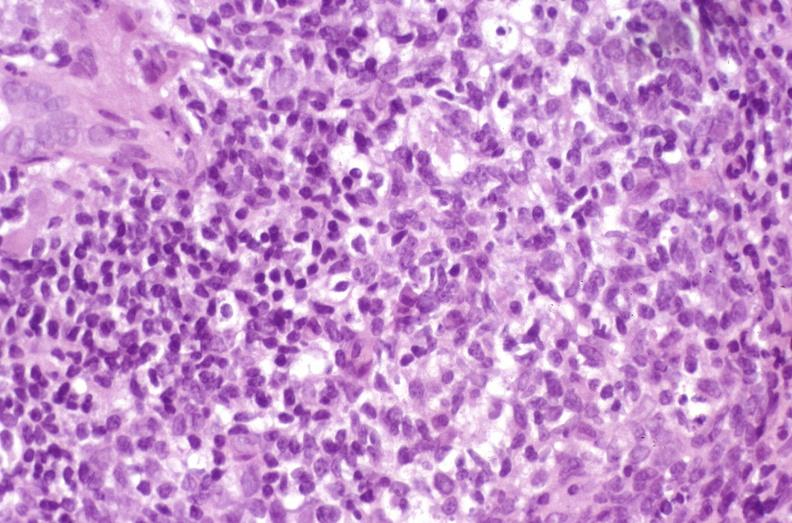what is present?
Answer the question using a single word or phrase. Liver 